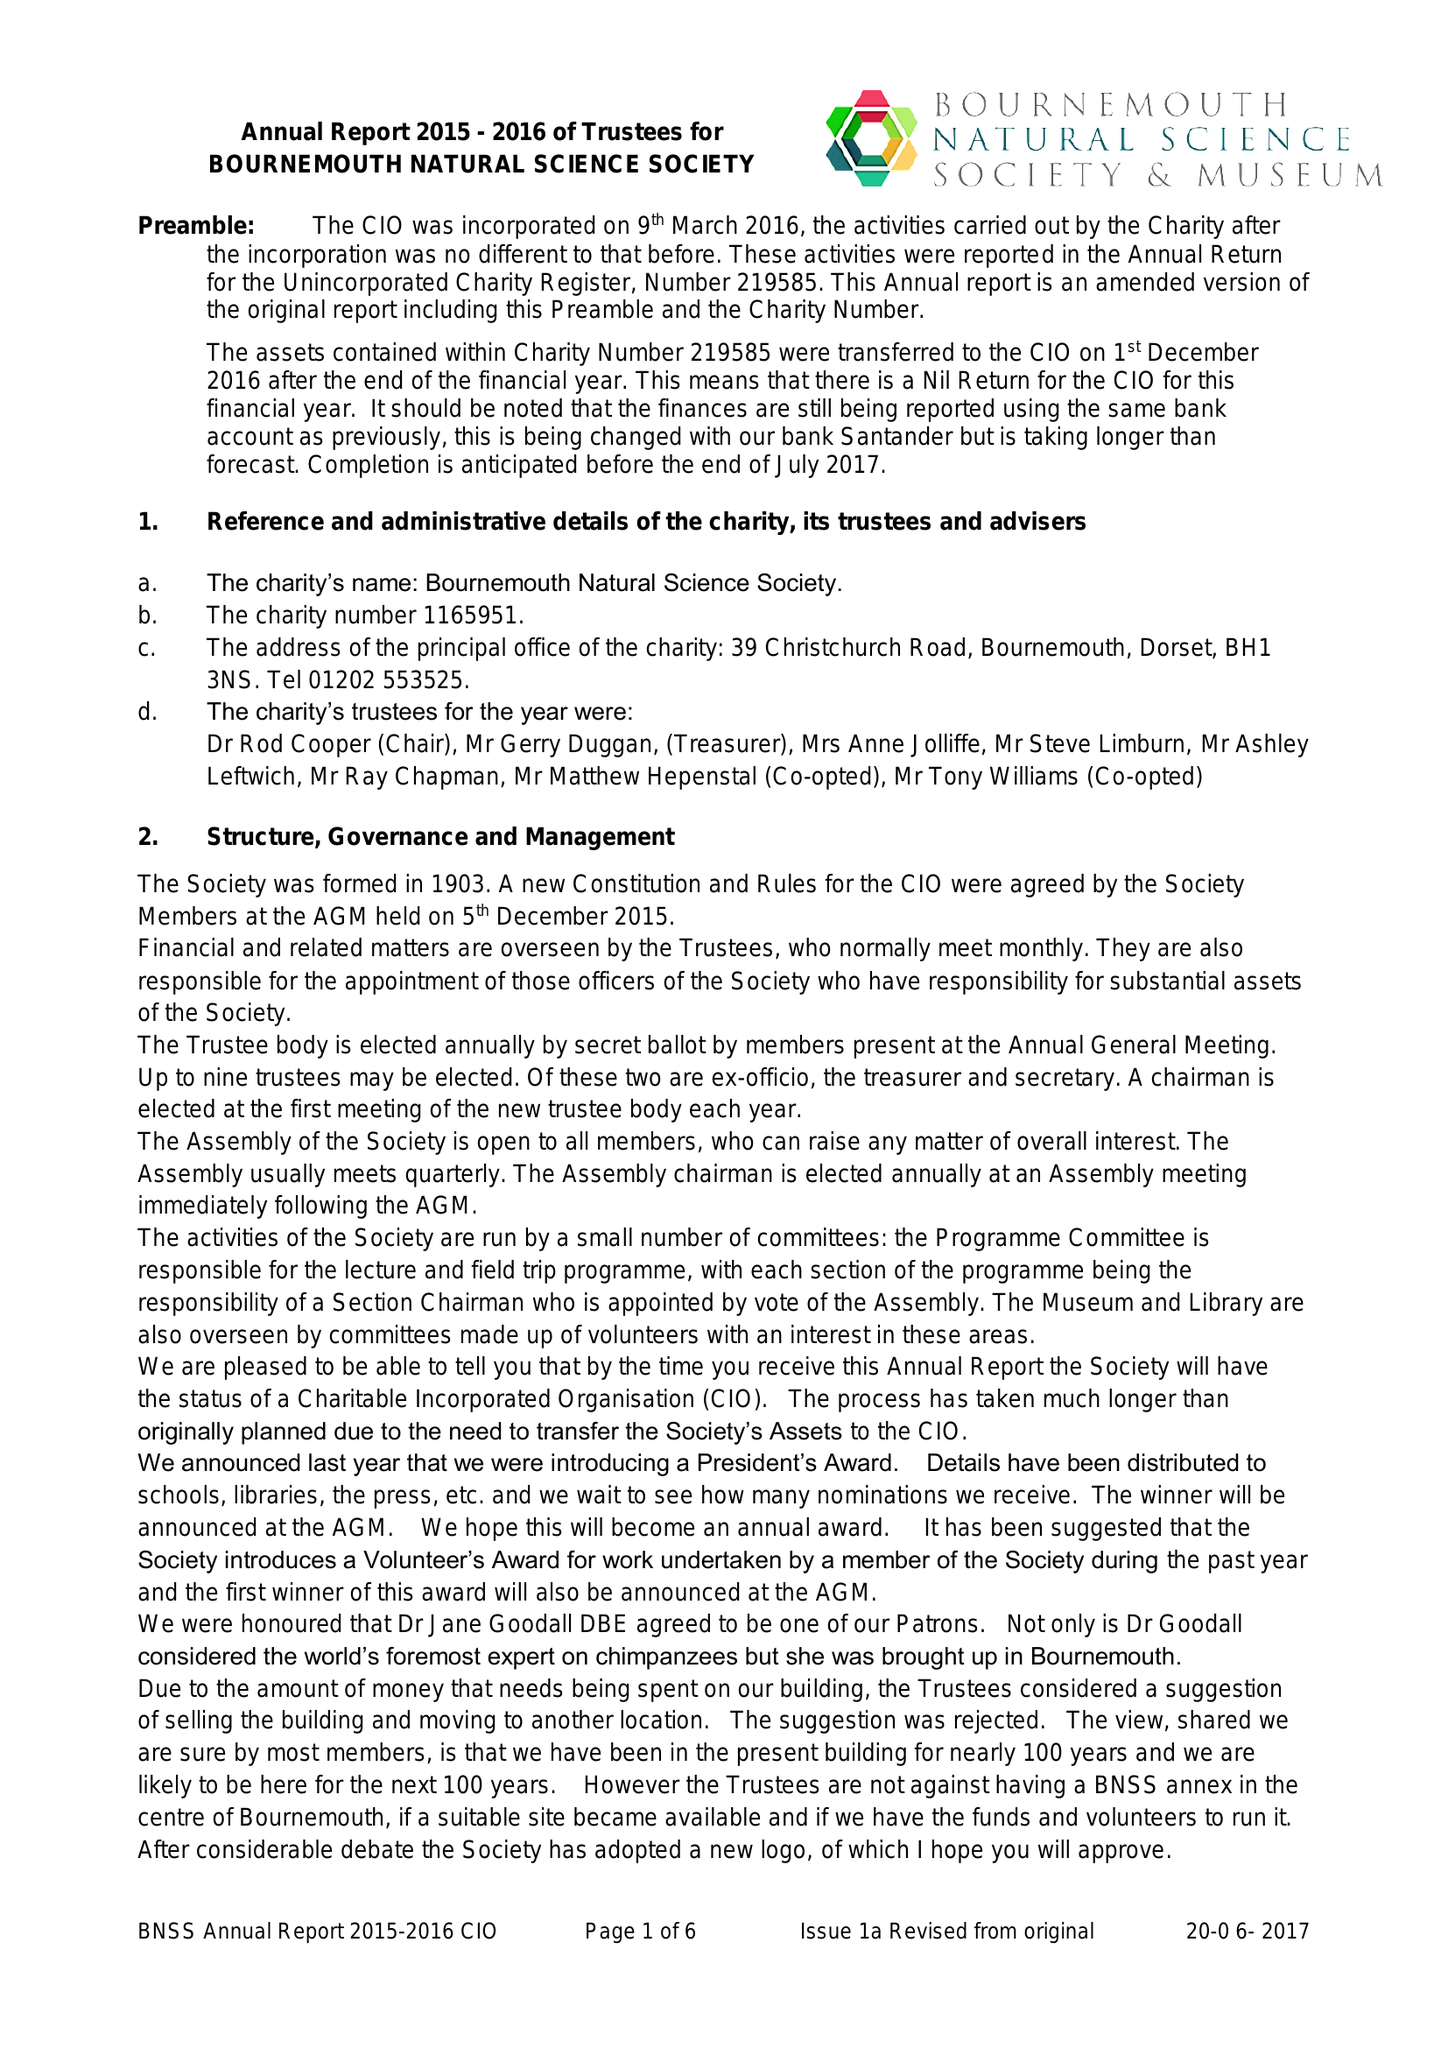What is the value for the address__postcode?
Answer the question using a single word or phrase. BH1 3NS 